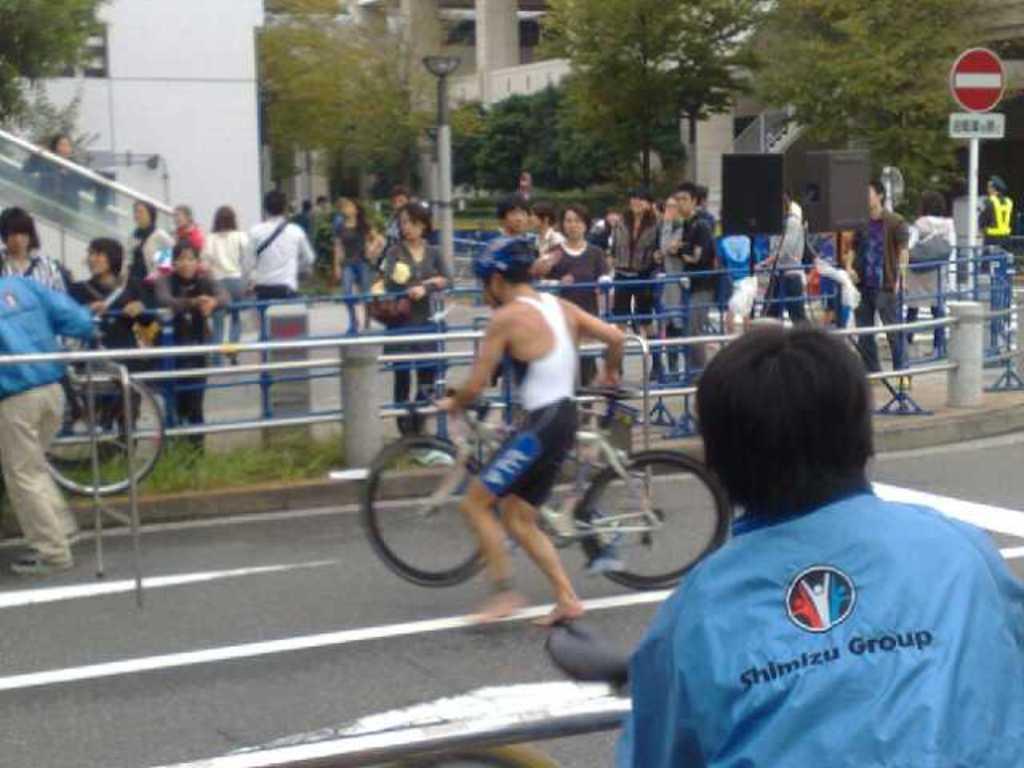How would you summarize this image in a sentence or two? This image is clicked outside. There are trees at the top. There are some persons standing in the middle. There are some persons who are riding bicycle in the middle. There are buildings at the top. 